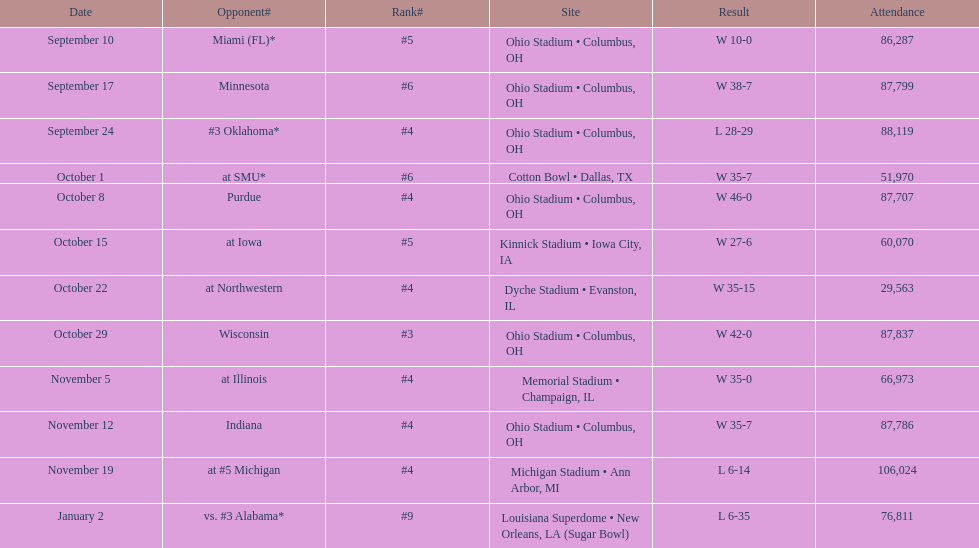In how many games were than more than 80,000 people attending 7. 